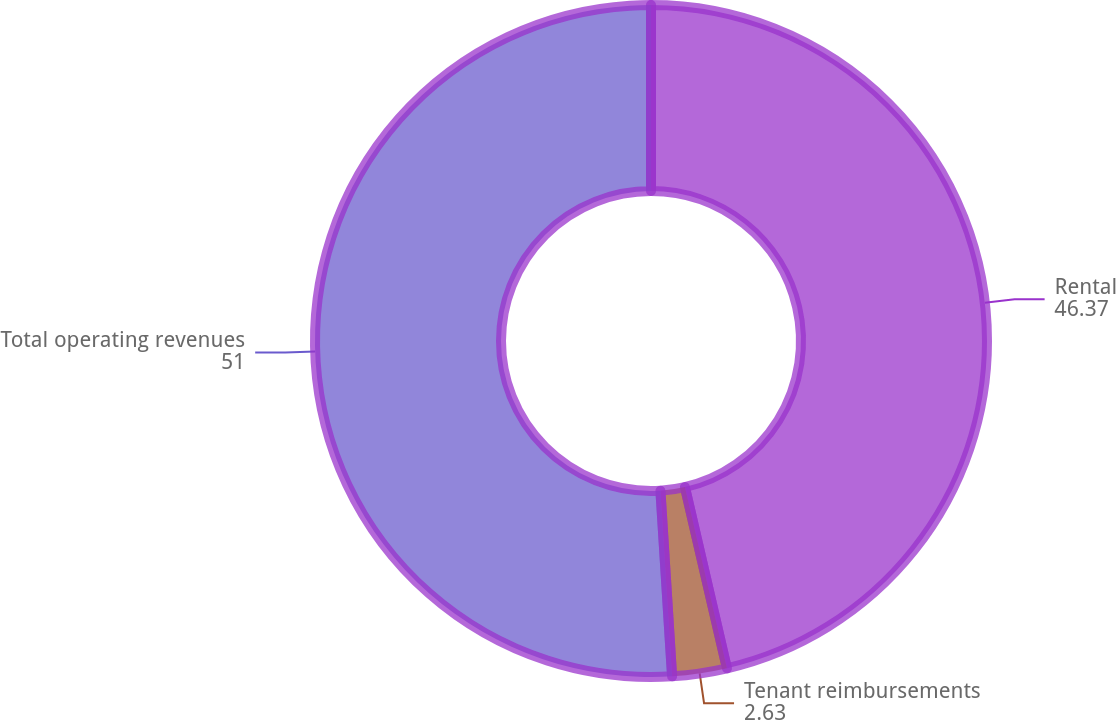Convert chart to OTSL. <chart><loc_0><loc_0><loc_500><loc_500><pie_chart><fcel>Rental<fcel>Tenant reimbursements<fcel>Total operating revenues<nl><fcel>46.37%<fcel>2.63%<fcel>51.0%<nl></chart> 